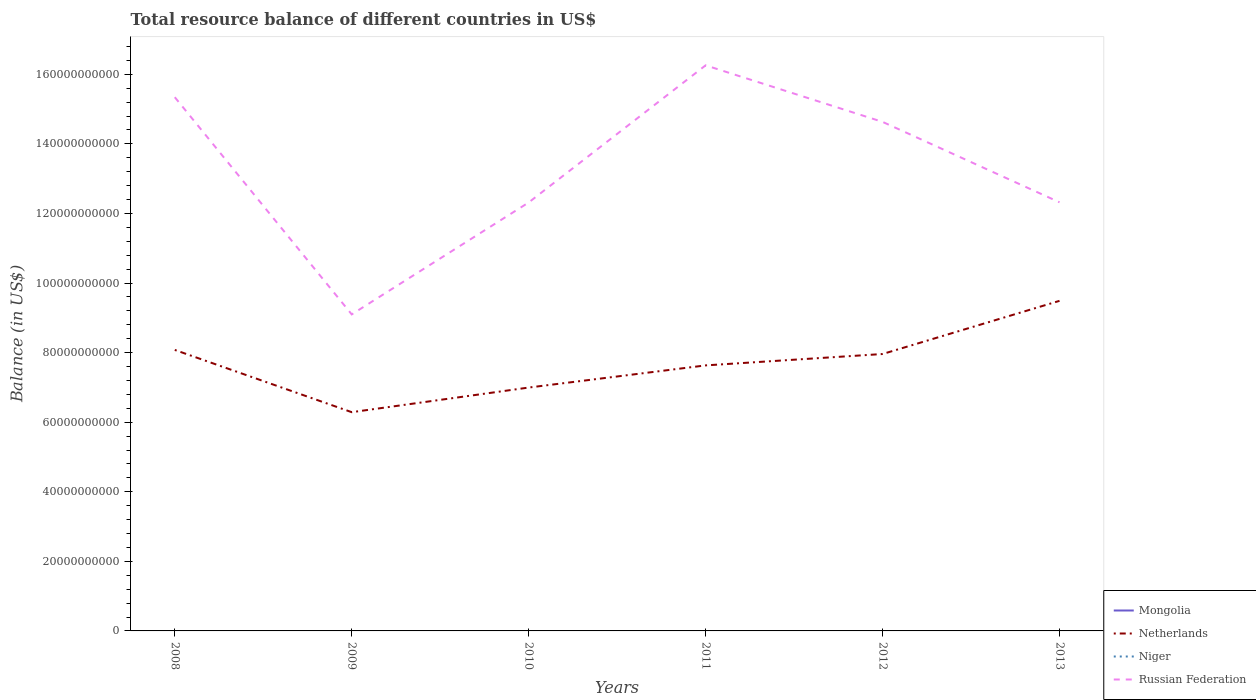Across all years, what is the maximum total resource balance in Russian Federation?
Give a very brief answer. 9.10e+1. What is the total total resource balance in Netherlands in the graph?
Provide a succinct answer. -1.34e+1. What is the difference between the highest and the second highest total resource balance in Netherlands?
Give a very brief answer. 3.20e+1. How many lines are there?
Ensure brevity in your answer.  2. Does the graph contain any zero values?
Ensure brevity in your answer.  Yes. Does the graph contain grids?
Provide a succinct answer. No. Where does the legend appear in the graph?
Provide a short and direct response. Bottom right. How many legend labels are there?
Your answer should be very brief. 4. How are the legend labels stacked?
Provide a succinct answer. Vertical. What is the title of the graph?
Give a very brief answer. Total resource balance of different countries in US$. Does "Slovak Republic" appear as one of the legend labels in the graph?
Ensure brevity in your answer.  No. What is the label or title of the Y-axis?
Your answer should be compact. Balance (in US$). What is the Balance (in US$) of Mongolia in 2008?
Your response must be concise. 0. What is the Balance (in US$) of Netherlands in 2008?
Provide a short and direct response. 8.08e+1. What is the Balance (in US$) of Niger in 2008?
Your answer should be very brief. 0. What is the Balance (in US$) in Russian Federation in 2008?
Provide a succinct answer. 1.53e+11. What is the Balance (in US$) of Mongolia in 2009?
Give a very brief answer. 0. What is the Balance (in US$) in Netherlands in 2009?
Give a very brief answer. 6.29e+1. What is the Balance (in US$) of Niger in 2009?
Keep it short and to the point. 0. What is the Balance (in US$) in Russian Federation in 2009?
Offer a very short reply. 9.10e+1. What is the Balance (in US$) of Netherlands in 2010?
Provide a short and direct response. 7.00e+1. What is the Balance (in US$) of Russian Federation in 2010?
Give a very brief answer. 1.23e+11. What is the Balance (in US$) of Mongolia in 2011?
Keep it short and to the point. 0. What is the Balance (in US$) of Netherlands in 2011?
Your answer should be very brief. 7.63e+1. What is the Balance (in US$) in Russian Federation in 2011?
Keep it short and to the point. 1.63e+11. What is the Balance (in US$) in Mongolia in 2012?
Offer a very short reply. 0. What is the Balance (in US$) of Netherlands in 2012?
Your answer should be very brief. 7.96e+1. What is the Balance (in US$) in Niger in 2012?
Make the answer very short. 0. What is the Balance (in US$) of Russian Federation in 2012?
Offer a very short reply. 1.46e+11. What is the Balance (in US$) in Mongolia in 2013?
Offer a terse response. 0. What is the Balance (in US$) in Netherlands in 2013?
Make the answer very short. 9.49e+1. What is the Balance (in US$) in Russian Federation in 2013?
Make the answer very short. 1.23e+11. Across all years, what is the maximum Balance (in US$) of Netherlands?
Give a very brief answer. 9.49e+1. Across all years, what is the maximum Balance (in US$) of Russian Federation?
Ensure brevity in your answer.  1.63e+11. Across all years, what is the minimum Balance (in US$) of Netherlands?
Provide a short and direct response. 6.29e+1. Across all years, what is the minimum Balance (in US$) of Russian Federation?
Make the answer very short. 9.10e+1. What is the total Balance (in US$) of Mongolia in the graph?
Offer a very short reply. 0. What is the total Balance (in US$) of Netherlands in the graph?
Keep it short and to the point. 4.64e+11. What is the total Balance (in US$) of Russian Federation in the graph?
Provide a succinct answer. 8.00e+11. What is the difference between the Balance (in US$) in Netherlands in 2008 and that in 2009?
Offer a terse response. 1.79e+1. What is the difference between the Balance (in US$) of Russian Federation in 2008 and that in 2009?
Provide a succinct answer. 6.24e+1. What is the difference between the Balance (in US$) in Netherlands in 2008 and that in 2010?
Offer a terse response. 1.08e+1. What is the difference between the Balance (in US$) of Russian Federation in 2008 and that in 2010?
Keep it short and to the point. 3.03e+1. What is the difference between the Balance (in US$) in Netherlands in 2008 and that in 2011?
Keep it short and to the point. 4.45e+09. What is the difference between the Balance (in US$) in Russian Federation in 2008 and that in 2011?
Keep it short and to the point. -9.16e+09. What is the difference between the Balance (in US$) in Netherlands in 2008 and that in 2012?
Offer a very short reply. 1.17e+09. What is the difference between the Balance (in US$) in Russian Federation in 2008 and that in 2012?
Give a very brief answer. 7.10e+09. What is the difference between the Balance (in US$) of Netherlands in 2008 and that in 2013?
Offer a terse response. -1.41e+1. What is the difference between the Balance (in US$) in Russian Federation in 2008 and that in 2013?
Your answer should be very brief. 3.02e+1. What is the difference between the Balance (in US$) of Netherlands in 2009 and that in 2010?
Give a very brief answer. -7.08e+09. What is the difference between the Balance (in US$) of Russian Federation in 2009 and that in 2010?
Keep it short and to the point. -3.22e+1. What is the difference between the Balance (in US$) of Netherlands in 2009 and that in 2011?
Keep it short and to the point. -1.34e+1. What is the difference between the Balance (in US$) in Russian Federation in 2009 and that in 2011?
Your response must be concise. -7.16e+1. What is the difference between the Balance (in US$) of Netherlands in 2009 and that in 2012?
Provide a short and direct response. -1.67e+1. What is the difference between the Balance (in US$) of Russian Federation in 2009 and that in 2012?
Offer a terse response. -5.53e+1. What is the difference between the Balance (in US$) of Netherlands in 2009 and that in 2013?
Provide a short and direct response. -3.20e+1. What is the difference between the Balance (in US$) of Russian Federation in 2009 and that in 2013?
Your response must be concise. -3.22e+1. What is the difference between the Balance (in US$) of Netherlands in 2010 and that in 2011?
Provide a succinct answer. -6.37e+09. What is the difference between the Balance (in US$) of Russian Federation in 2010 and that in 2011?
Your answer should be very brief. -3.94e+1. What is the difference between the Balance (in US$) in Netherlands in 2010 and that in 2012?
Your answer should be compact. -9.64e+09. What is the difference between the Balance (in US$) in Russian Federation in 2010 and that in 2012?
Ensure brevity in your answer.  -2.32e+1. What is the difference between the Balance (in US$) in Netherlands in 2010 and that in 2013?
Provide a succinct answer. -2.49e+1. What is the difference between the Balance (in US$) of Russian Federation in 2010 and that in 2013?
Your answer should be very brief. -5.26e+07. What is the difference between the Balance (in US$) of Netherlands in 2011 and that in 2012?
Give a very brief answer. -3.27e+09. What is the difference between the Balance (in US$) of Russian Federation in 2011 and that in 2012?
Provide a short and direct response. 1.63e+1. What is the difference between the Balance (in US$) of Netherlands in 2011 and that in 2013?
Your answer should be very brief. -1.86e+1. What is the difference between the Balance (in US$) of Russian Federation in 2011 and that in 2013?
Provide a short and direct response. 3.94e+1. What is the difference between the Balance (in US$) of Netherlands in 2012 and that in 2013?
Provide a succinct answer. -1.53e+1. What is the difference between the Balance (in US$) of Russian Federation in 2012 and that in 2013?
Keep it short and to the point. 2.31e+1. What is the difference between the Balance (in US$) in Netherlands in 2008 and the Balance (in US$) in Russian Federation in 2009?
Provide a short and direct response. -1.02e+1. What is the difference between the Balance (in US$) of Netherlands in 2008 and the Balance (in US$) of Russian Federation in 2010?
Keep it short and to the point. -4.24e+1. What is the difference between the Balance (in US$) of Netherlands in 2008 and the Balance (in US$) of Russian Federation in 2011?
Ensure brevity in your answer.  -8.18e+1. What is the difference between the Balance (in US$) of Netherlands in 2008 and the Balance (in US$) of Russian Federation in 2012?
Make the answer very short. -6.55e+1. What is the difference between the Balance (in US$) in Netherlands in 2008 and the Balance (in US$) in Russian Federation in 2013?
Ensure brevity in your answer.  -4.24e+1. What is the difference between the Balance (in US$) of Netherlands in 2009 and the Balance (in US$) of Russian Federation in 2010?
Ensure brevity in your answer.  -6.03e+1. What is the difference between the Balance (in US$) in Netherlands in 2009 and the Balance (in US$) in Russian Federation in 2011?
Make the answer very short. -9.97e+1. What is the difference between the Balance (in US$) in Netherlands in 2009 and the Balance (in US$) in Russian Federation in 2012?
Give a very brief answer. -8.34e+1. What is the difference between the Balance (in US$) in Netherlands in 2009 and the Balance (in US$) in Russian Federation in 2013?
Your response must be concise. -6.03e+1. What is the difference between the Balance (in US$) of Netherlands in 2010 and the Balance (in US$) of Russian Federation in 2011?
Your answer should be very brief. -9.26e+1. What is the difference between the Balance (in US$) in Netherlands in 2010 and the Balance (in US$) in Russian Federation in 2012?
Ensure brevity in your answer.  -7.64e+1. What is the difference between the Balance (in US$) in Netherlands in 2010 and the Balance (in US$) in Russian Federation in 2013?
Your response must be concise. -5.32e+1. What is the difference between the Balance (in US$) in Netherlands in 2011 and the Balance (in US$) in Russian Federation in 2012?
Ensure brevity in your answer.  -7.00e+1. What is the difference between the Balance (in US$) in Netherlands in 2011 and the Balance (in US$) in Russian Federation in 2013?
Your answer should be very brief. -4.69e+1. What is the difference between the Balance (in US$) in Netherlands in 2012 and the Balance (in US$) in Russian Federation in 2013?
Provide a succinct answer. -4.36e+1. What is the average Balance (in US$) in Netherlands per year?
Give a very brief answer. 7.74e+1. What is the average Balance (in US$) in Niger per year?
Make the answer very short. 0. What is the average Balance (in US$) of Russian Federation per year?
Offer a very short reply. 1.33e+11. In the year 2008, what is the difference between the Balance (in US$) of Netherlands and Balance (in US$) of Russian Federation?
Make the answer very short. -7.26e+1. In the year 2009, what is the difference between the Balance (in US$) in Netherlands and Balance (in US$) in Russian Federation?
Your answer should be compact. -2.81e+1. In the year 2010, what is the difference between the Balance (in US$) in Netherlands and Balance (in US$) in Russian Federation?
Your response must be concise. -5.32e+1. In the year 2011, what is the difference between the Balance (in US$) of Netherlands and Balance (in US$) of Russian Federation?
Ensure brevity in your answer.  -8.62e+1. In the year 2012, what is the difference between the Balance (in US$) of Netherlands and Balance (in US$) of Russian Federation?
Offer a terse response. -6.67e+1. In the year 2013, what is the difference between the Balance (in US$) of Netherlands and Balance (in US$) of Russian Federation?
Your answer should be compact. -2.83e+1. What is the ratio of the Balance (in US$) of Netherlands in 2008 to that in 2009?
Give a very brief answer. 1.28. What is the ratio of the Balance (in US$) of Russian Federation in 2008 to that in 2009?
Make the answer very short. 1.69. What is the ratio of the Balance (in US$) of Netherlands in 2008 to that in 2010?
Ensure brevity in your answer.  1.15. What is the ratio of the Balance (in US$) of Russian Federation in 2008 to that in 2010?
Ensure brevity in your answer.  1.25. What is the ratio of the Balance (in US$) in Netherlands in 2008 to that in 2011?
Keep it short and to the point. 1.06. What is the ratio of the Balance (in US$) in Russian Federation in 2008 to that in 2011?
Provide a succinct answer. 0.94. What is the ratio of the Balance (in US$) of Netherlands in 2008 to that in 2012?
Give a very brief answer. 1.01. What is the ratio of the Balance (in US$) of Russian Federation in 2008 to that in 2012?
Your answer should be very brief. 1.05. What is the ratio of the Balance (in US$) in Netherlands in 2008 to that in 2013?
Provide a short and direct response. 0.85. What is the ratio of the Balance (in US$) of Russian Federation in 2008 to that in 2013?
Give a very brief answer. 1.25. What is the ratio of the Balance (in US$) in Netherlands in 2009 to that in 2010?
Your answer should be very brief. 0.9. What is the ratio of the Balance (in US$) in Russian Federation in 2009 to that in 2010?
Make the answer very short. 0.74. What is the ratio of the Balance (in US$) of Netherlands in 2009 to that in 2011?
Offer a very short reply. 0.82. What is the ratio of the Balance (in US$) of Russian Federation in 2009 to that in 2011?
Make the answer very short. 0.56. What is the ratio of the Balance (in US$) in Netherlands in 2009 to that in 2012?
Provide a short and direct response. 0.79. What is the ratio of the Balance (in US$) of Russian Federation in 2009 to that in 2012?
Your answer should be compact. 0.62. What is the ratio of the Balance (in US$) in Netherlands in 2009 to that in 2013?
Your answer should be very brief. 0.66. What is the ratio of the Balance (in US$) in Russian Federation in 2009 to that in 2013?
Your answer should be very brief. 0.74. What is the ratio of the Balance (in US$) in Netherlands in 2010 to that in 2011?
Your answer should be compact. 0.92. What is the ratio of the Balance (in US$) of Russian Federation in 2010 to that in 2011?
Ensure brevity in your answer.  0.76. What is the ratio of the Balance (in US$) of Netherlands in 2010 to that in 2012?
Offer a very short reply. 0.88. What is the ratio of the Balance (in US$) in Russian Federation in 2010 to that in 2012?
Provide a succinct answer. 0.84. What is the ratio of the Balance (in US$) in Netherlands in 2010 to that in 2013?
Make the answer very short. 0.74. What is the ratio of the Balance (in US$) in Netherlands in 2011 to that in 2012?
Your response must be concise. 0.96. What is the ratio of the Balance (in US$) of Russian Federation in 2011 to that in 2012?
Provide a succinct answer. 1.11. What is the ratio of the Balance (in US$) of Netherlands in 2011 to that in 2013?
Provide a short and direct response. 0.8. What is the ratio of the Balance (in US$) of Russian Federation in 2011 to that in 2013?
Ensure brevity in your answer.  1.32. What is the ratio of the Balance (in US$) of Netherlands in 2012 to that in 2013?
Keep it short and to the point. 0.84. What is the ratio of the Balance (in US$) in Russian Federation in 2012 to that in 2013?
Ensure brevity in your answer.  1.19. What is the difference between the highest and the second highest Balance (in US$) in Netherlands?
Your response must be concise. 1.41e+1. What is the difference between the highest and the second highest Balance (in US$) of Russian Federation?
Offer a very short reply. 9.16e+09. What is the difference between the highest and the lowest Balance (in US$) of Netherlands?
Your response must be concise. 3.20e+1. What is the difference between the highest and the lowest Balance (in US$) in Russian Federation?
Provide a succinct answer. 7.16e+1. 